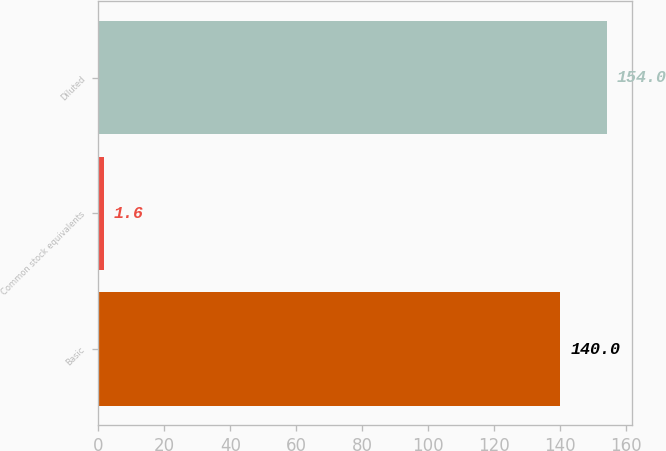Convert chart to OTSL. <chart><loc_0><loc_0><loc_500><loc_500><bar_chart><fcel>Basic<fcel>Common stock equivalents<fcel>Diluted<nl><fcel>140<fcel>1.6<fcel>154<nl></chart> 